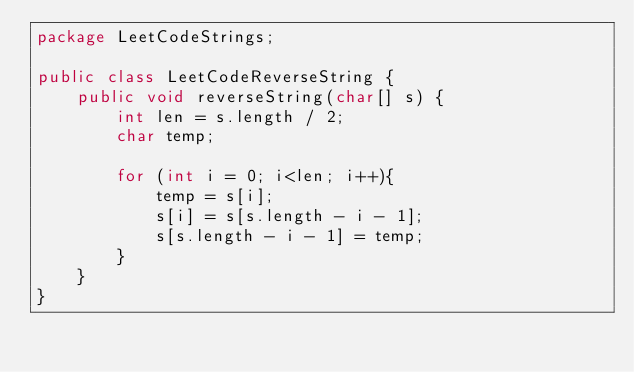<code> <loc_0><loc_0><loc_500><loc_500><_Java_>package LeetCodeStrings;

public class LeetCodeReverseString {
    public void reverseString(char[] s) {
        int len = s.length / 2;
        char temp;

        for (int i = 0; i<len; i++){
            temp = s[i];
            s[i] = s[s.length - i - 1];
            s[s.length - i - 1] = temp;
        }
    }
}
</code> 